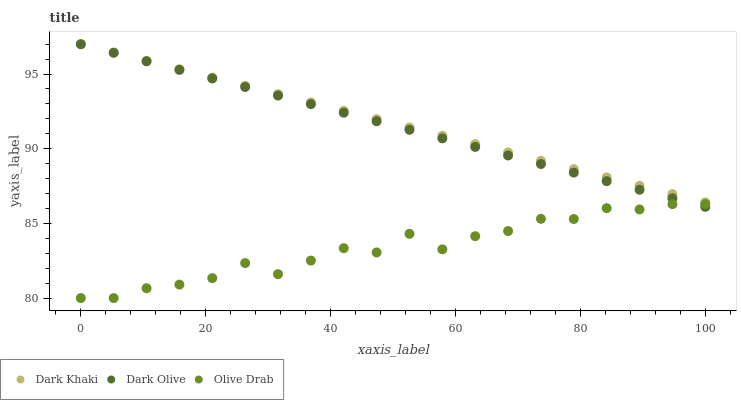Does Olive Drab have the minimum area under the curve?
Answer yes or no. Yes. Does Dark Khaki have the maximum area under the curve?
Answer yes or no. Yes. Does Dark Olive have the minimum area under the curve?
Answer yes or no. No. Does Dark Olive have the maximum area under the curve?
Answer yes or no. No. Is Dark Khaki the smoothest?
Answer yes or no. Yes. Is Olive Drab the roughest?
Answer yes or no. Yes. Is Dark Olive the smoothest?
Answer yes or no. No. Is Dark Olive the roughest?
Answer yes or no. No. Does Olive Drab have the lowest value?
Answer yes or no. Yes. Does Dark Olive have the lowest value?
Answer yes or no. No. Does Dark Olive have the highest value?
Answer yes or no. Yes. Does Olive Drab have the highest value?
Answer yes or no. No. Is Olive Drab less than Dark Khaki?
Answer yes or no. Yes. Is Dark Khaki greater than Olive Drab?
Answer yes or no. Yes. Does Dark Olive intersect Dark Khaki?
Answer yes or no. Yes. Is Dark Olive less than Dark Khaki?
Answer yes or no. No. Is Dark Olive greater than Dark Khaki?
Answer yes or no. No. Does Olive Drab intersect Dark Khaki?
Answer yes or no. No. 